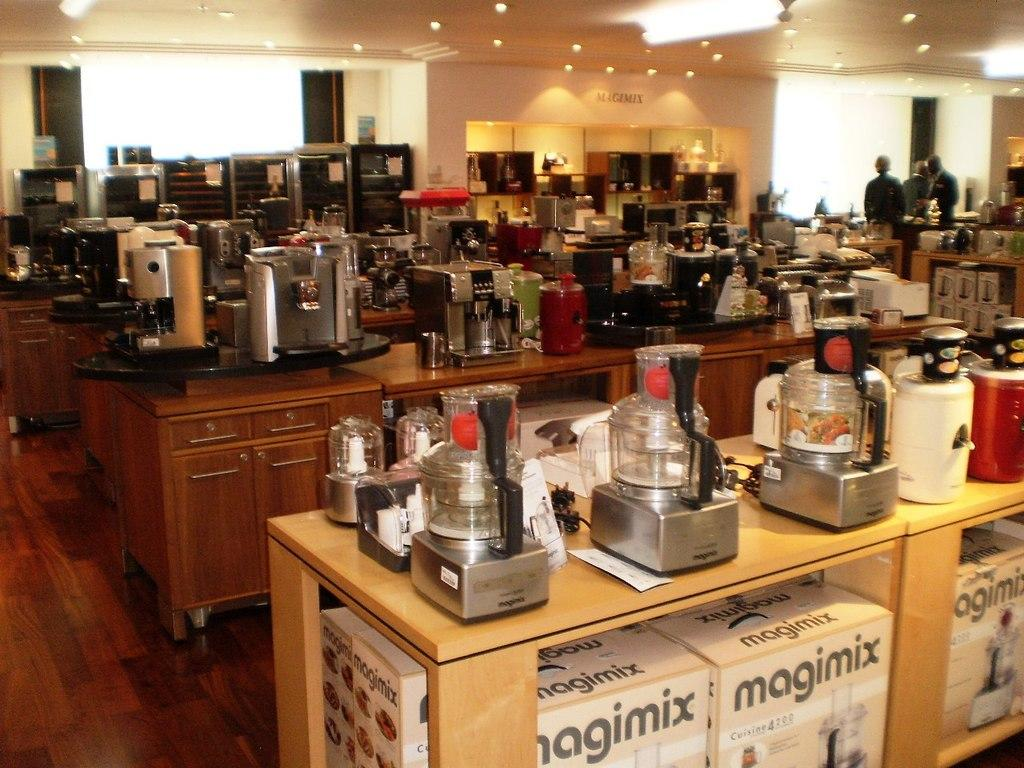Provide a one-sentence caption for the provided image. Magimix blenders are arranged on a wooden counter in this store. 